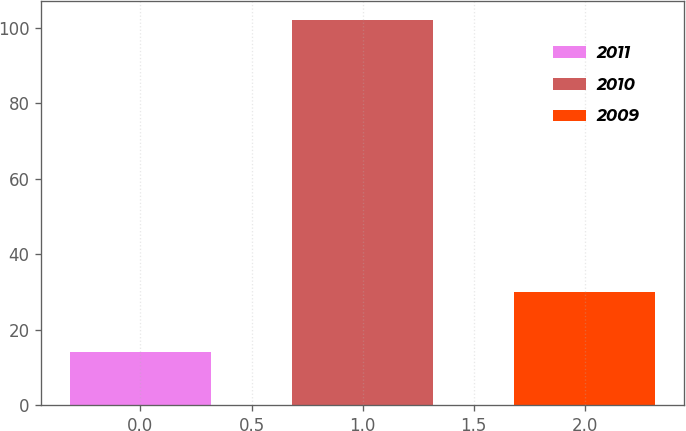Convert chart. <chart><loc_0><loc_0><loc_500><loc_500><bar_chart><fcel>2011<fcel>2010<fcel>2009<nl><fcel>14<fcel>102<fcel>30<nl></chart> 